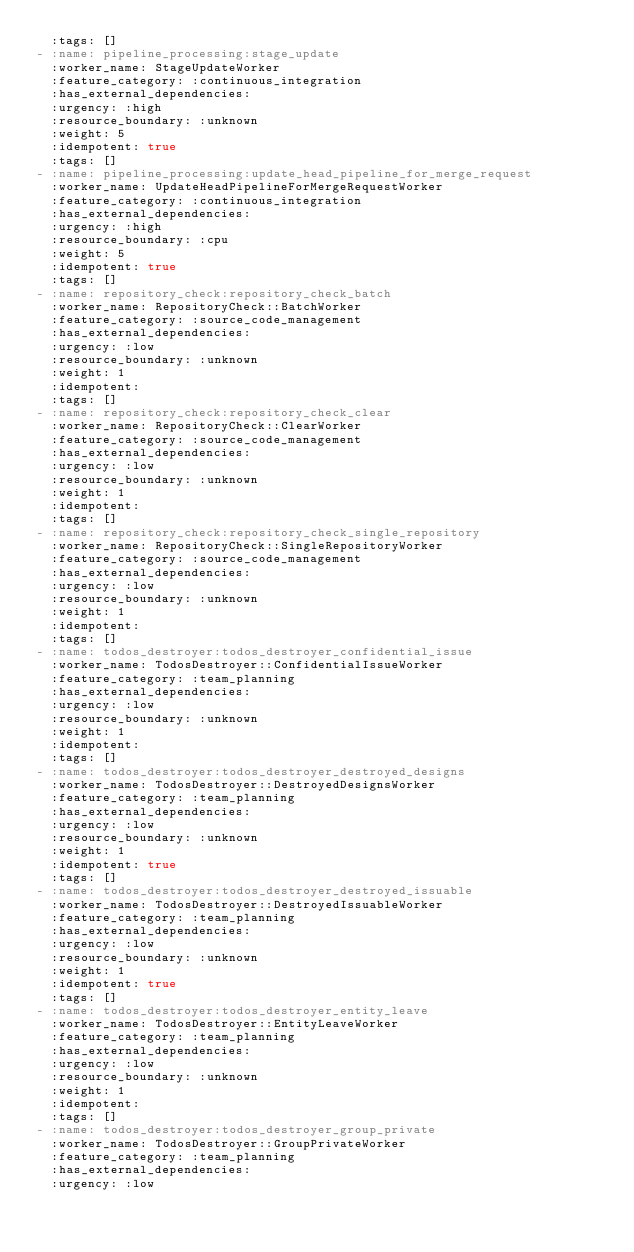Convert code to text. <code><loc_0><loc_0><loc_500><loc_500><_YAML_>  :tags: []
- :name: pipeline_processing:stage_update
  :worker_name: StageUpdateWorker
  :feature_category: :continuous_integration
  :has_external_dependencies:
  :urgency: :high
  :resource_boundary: :unknown
  :weight: 5
  :idempotent: true
  :tags: []
- :name: pipeline_processing:update_head_pipeline_for_merge_request
  :worker_name: UpdateHeadPipelineForMergeRequestWorker
  :feature_category: :continuous_integration
  :has_external_dependencies:
  :urgency: :high
  :resource_boundary: :cpu
  :weight: 5
  :idempotent: true
  :tags: []
- :name: repository_check:repository_check_batch
  :worker_name: RepositoryCheck::BatchWorker
  :feature_category: :source_code_management
  :has_external_dependencies:
  :urgency: :low
  :resource_boundary: :unknown
  :weight: 1
  :idempotent:
  :tags: []
- :name: repository_check:repository_check_clear
  :worker_name: RepositoryCheck::ClearWorker
  :feature_category: :source_code_management
  :has_external_dependencies:
  :urgency: :low
  :resource_boundary: :unknown
  :weight: 1
  :idempotent:
  :tags: []
- :name: repository_check:repository_check_single_repository
  :worker_name: RepositoryCheck::SingleRepositoryWorker
  :feature_category: :source_code_management
  :has_external_dependencies:
  :urgency: :low
  :resource_boundary: :unknown
  :weight: 1
  :idempotent:
  :tags: []
- :name: todos_destroyer:todos_destroyer_confidential_issue
  :worker_name: TodosDestroyer::ConfidentialIssueWorker
  :feature_category: :team_planning
  :has_external_dependencies:
  :urgency: :low
  :resource_boundary: :unknown
  :weight: 1
  :idempotent:
  :tags: []
- :name: todos_destroyer:todos_destroyer_destroyed_designs
  :worker_name: TodosDestroyer::DestroyedDesignsWorker
  :feature_category: :team_planning
  :has_external_dependencies:
  :urgency: :low
  :resource_boundary: :unknown
  :weight: 1
  :idempotent: true
  :tags: []
- :name: todos_destroyer:todos_destroyer_destroyed_issuable
  :worker_name: TodosDestroyer::DestroyedIssuableWorker
  :feature_category: :team_planning
  :has_external_dependencies:
  :urgency: :low
  :resource_boundary: :unknown
  :weight: 1
  :idempotent: true
  :tags: []
- :name: todos_destroyer:todos_destroyer_entity_leave
  :worker_name: TodosDestroyer::EntityLeaveWorker
  :feature_category: :team_planning
  :has_external_dependencies:
  :urgency: :low
  :resource_boundary: :unknown
  :weight: 1
  :idempotent:
  :tags: []
- :name: todos_destroyer:todos_destroyer_group_private
  :worker_name: TodosDestroyer::GroupPrivateWorker
  :feature_category: :team_planning
  :has_external_dependencies:
  :urgency: :low</code> 